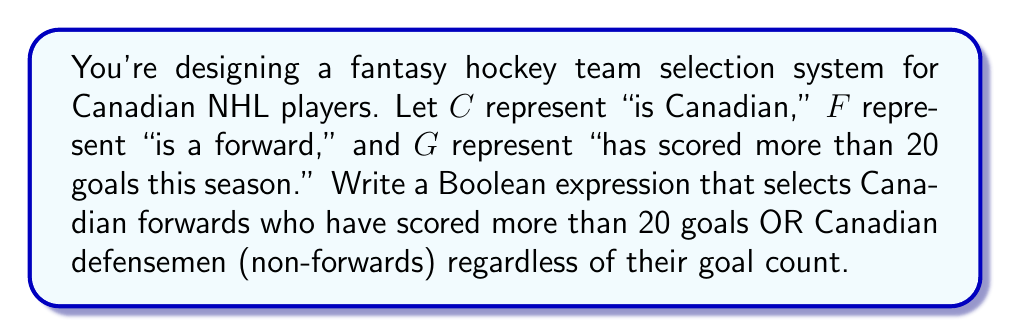Help me with this question. Let's break this down step-by-step:

1) First, we need to express "Canadian forwards who have scored more than 20 goals":
   $C \land F \land G$

2) Next, we need to express "Canadian defensemen (non-forwards) regardless of their goal count":
   $C \land \lnot F$

3) We want players who fit either of these criteria, so we use the OR operator ($\lor$) to combine them:
   $(C \land F \land G) \lor (C \land \lnot F)$

4) We can factor out the common term $C$:
   $C \land (F \land G \lor \lnot F)$

This Boolean expression will select players who are Canadian AND either (forwards with more than 20 goals OR not forwards).

To verify:
- A Canadian forward with 25 goals: $C \land (T \land T \lor F) = C \land (T \lor F) = C \land T = C$
- A Canadian defenseman with 5 goals: $C \land (F \land F \lor T) = C \land (F \lor T) = C \land T = C$
- A non-Canadian forward with 30 goals: $F \land (T \land T \lor F) = F \land T = F$

This matches our criteria for selecting players.
Answer: $C \land (F \land G \lor \lnot F)$ 